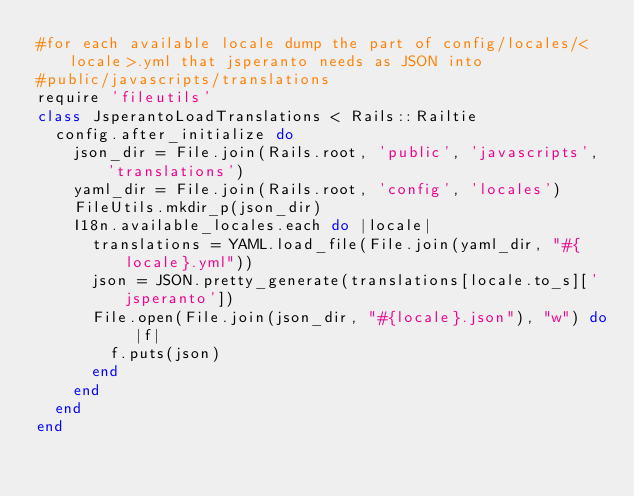<code> <loc_0><loc_0><loc_500><loc_500><_Ruby_>#for each available locale dump the part of config/locales/<locale>.yml that jsperanto needs as JSON into
#public/javascripts/translations
require 'fileutils'
class JsperantoLoadTranslations < Rails::Railtie
  config.after_initialize do
    json_dir = File.join(Rails.root, 'public', 'javascripts', 'translations')
    yaml_dir = File.join(Rails.root, 'config', 'locales')
    FileUtils.mkdir_p(json_dir)
    I18n.available_locales.each do |locale|
      translations = YAML.load_file(File.join(yaml_dir, "#{locale}.yml"))
      json = JSON.pretty_generate(translations[locale.to_s]['jsperanto'])
      File.open(File.join(json_dir, "#{locale}.json"), "w") do |f|
        f.puts(json)
      end
    end
  end
end
</code> 